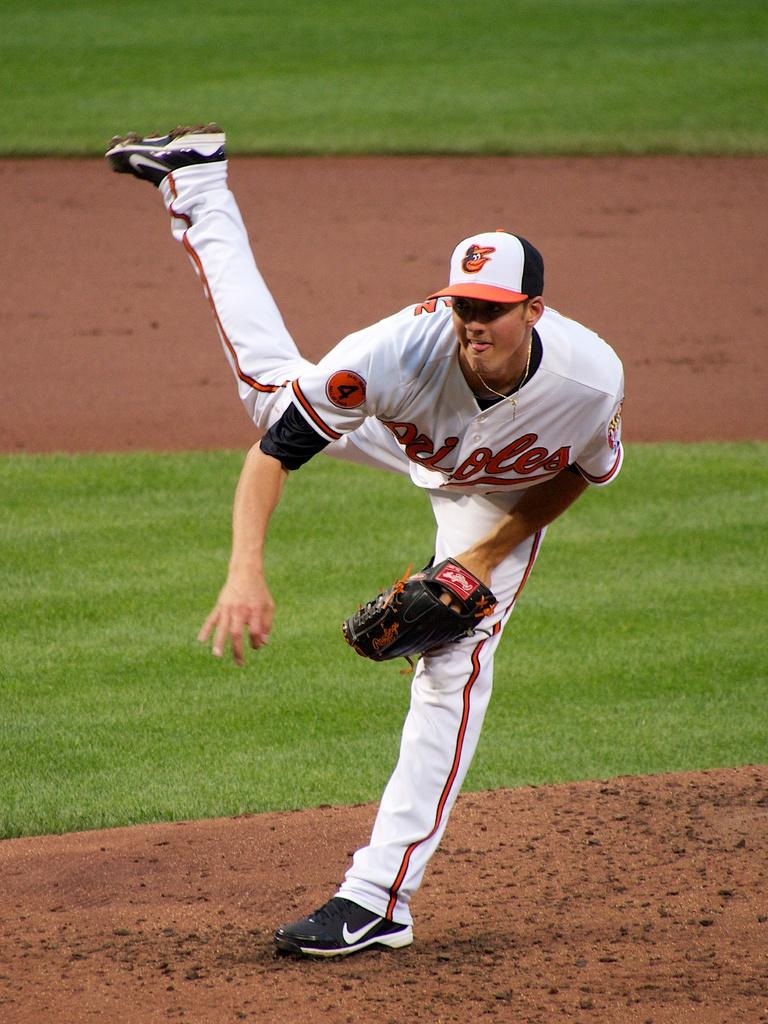Does his shirt say orioles on the front of it?
Offer a terse response. Yes. 